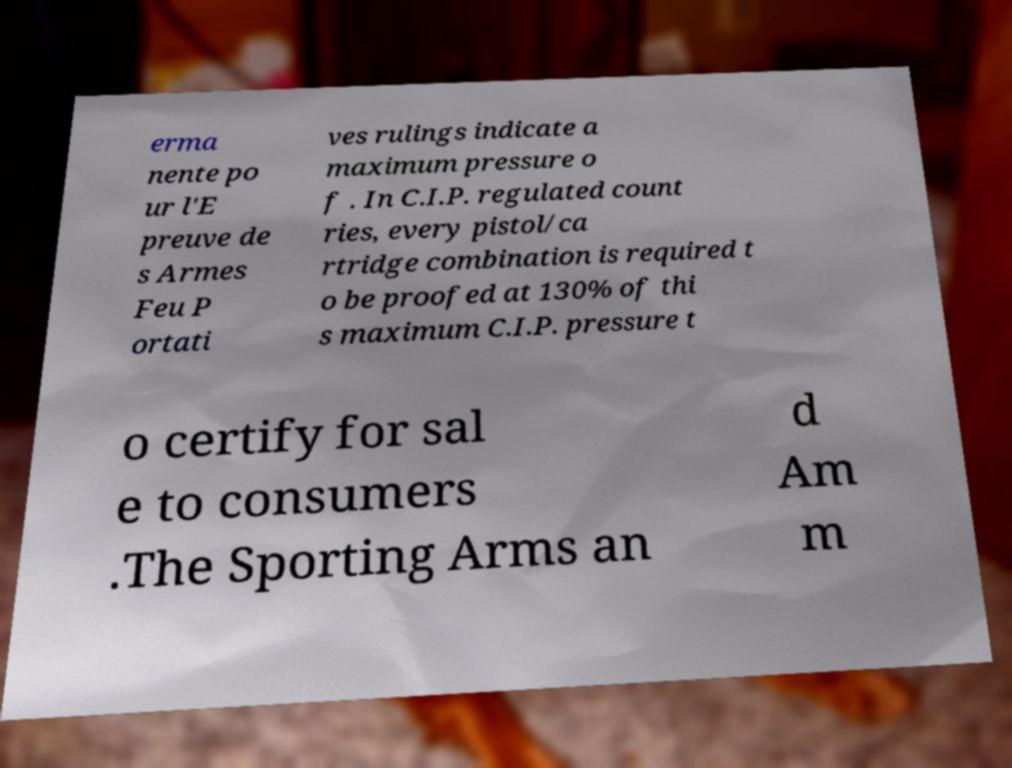For documentation purposes, I need the text within this image transcribed. Could you provide that? erma nente po ur l'E preuve de s Armes Feu P ortati ves rulings indicate a maximum pressure o f . In C.I.P. regulated count ries, every pistol/ca rtridge combination is required t o be proofed at 130% of thi s maximum C.I.P. pressure t o certify for sal e to consumers .The Sporting Arms an d Am m 